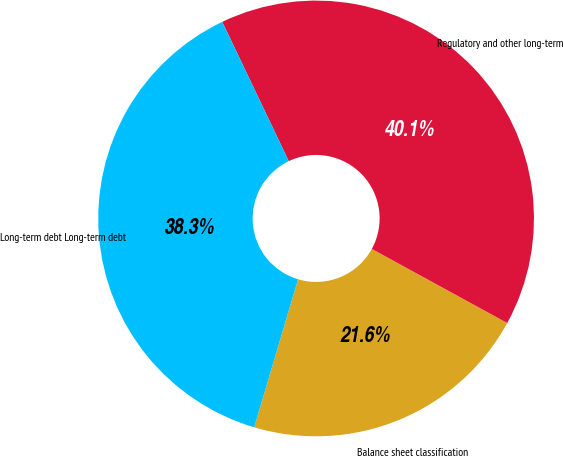Convert chart. <chart><loc_0><loc_0><loc_500><loc_500><pie_chart><fcel>Balance sheet classification<fcel>Regulatory and other long-term<fcel>Long-term debt Long-term debt<nl><fcel>21.62%<fcel>40.06%<fcel>38.32%<nl></chart> 